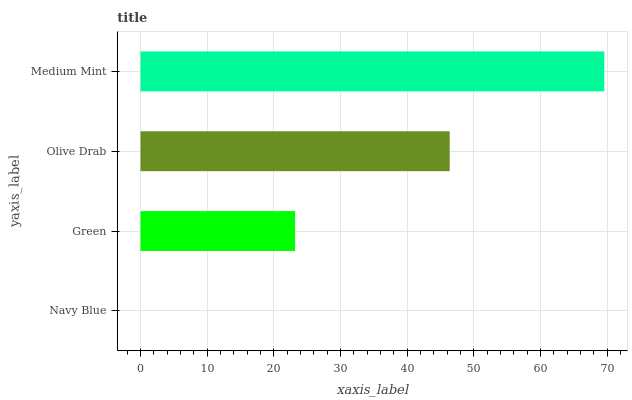Is Navy Blue the minimum?
Answer yes or no. Yes. Is Medium Mint the maximum?
Answer yes or no. Yes. Is Green the minimum?
Answer yes or no. No. Is Green the maximum?
Answer yes or no. No. Is Green greater than Navy Blue?
Answer yes or no. Yes. Is Navy Blue less than Green?
Answer yes or no. Yes. Is Navy Blue greater than Green?
Answer yes or no. No. Is Green less than Navy Blue?
Answer yes or no. No. Is Olive Drab the high median?
Answer yes or no. Yes. Is Green the low median?
Answer yes or no. Yes. Is Navy Blue the high median?
Answer yes or no. No. Is Navy Blue the low median?
Answer yes or no. No. 